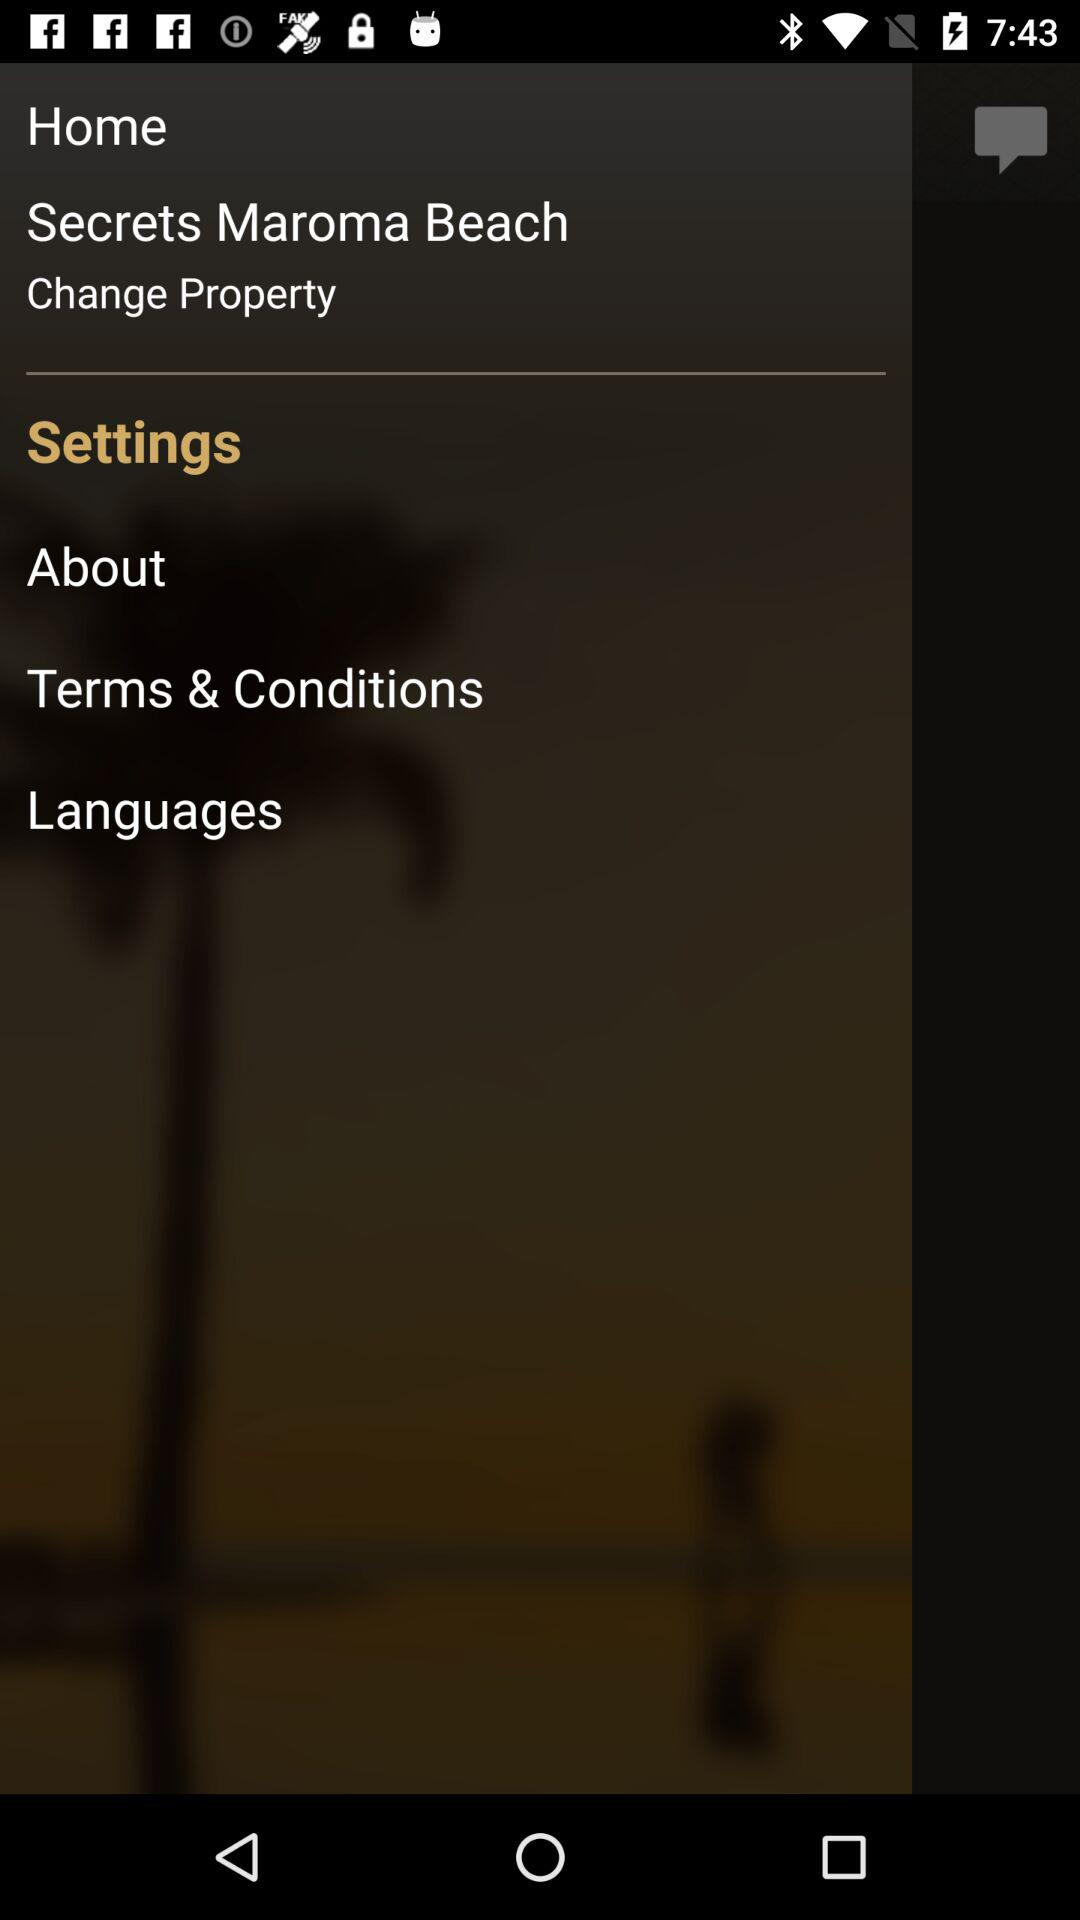Which tab is selected? The selected tab is "Settings". 